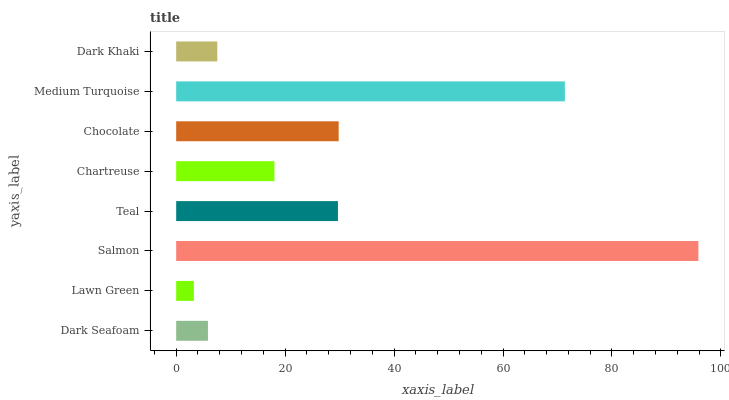Is Lawn Green the minimum?
Answer yes or no. Yes. Is Salmon the maximum?
Answer yes or no. Yes. Is Salmon the minimum?
Answer yes or no. No. Is Lawn Green the maximum?
Answer yes or no. No. Is Salmon greater than Lawn Green?
Answer yes or no. Yes. Is Lawn Green less than Salmon?
Answer yes or no. Yes. Is Lawn Green greater than Salmon?
Answer yes or no. No. Is Salmon less than Lawn Green?
Answer yes or no. No. Is Teal the high median?
Answer yes or no. Yes. Is Chartreuse the low median?
Answer yes or no. Yes. Is Dark Seafoam the high median?
Answer yes or no. No. Is Dark Khaki the low median?
Answer yes or no. No. 